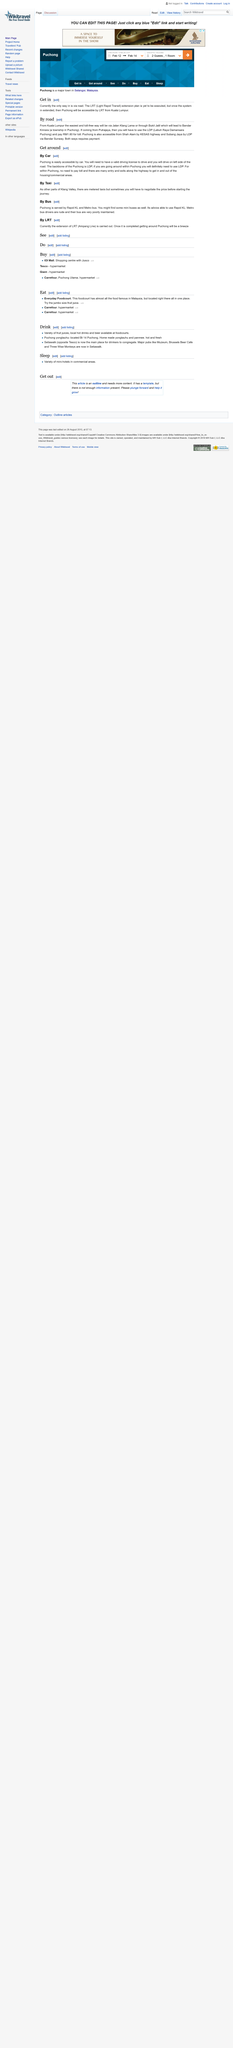Outline some significant characteristics in this image. Yes, Puchong can be reached conveniently by car from Shah Alam. It is customary to drive on the left side of the road in Puchong. The LDP toll costs RM 1.60. 